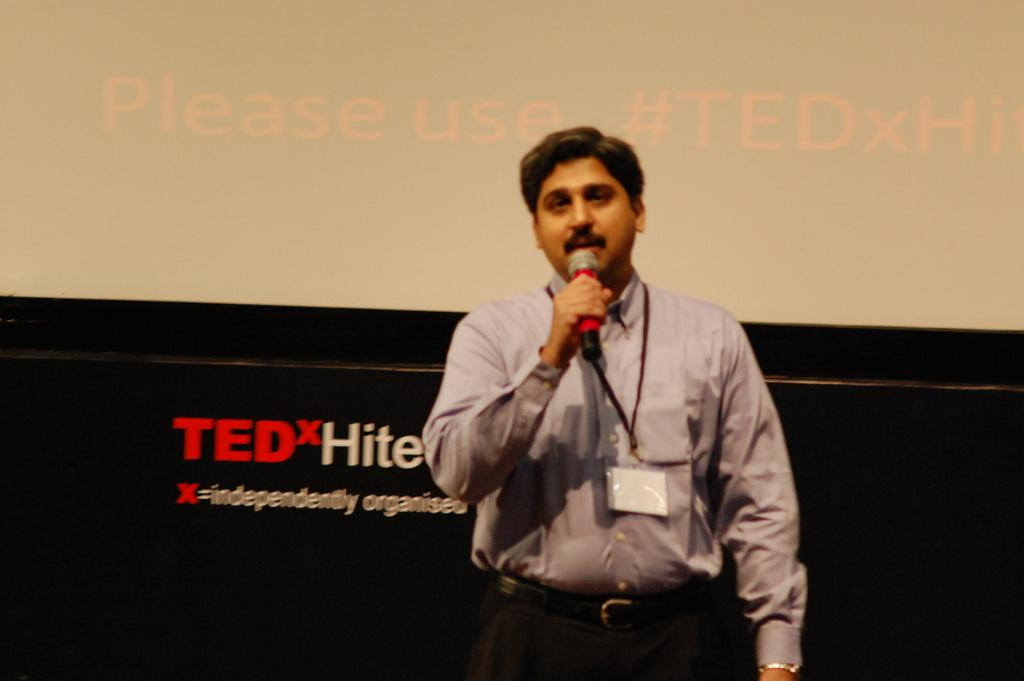What is the man doing on the stage in the image? The man is standing on the stage and talking. What is the man wearing that identifies him? The man is wearing an ID card. What is the man holding in his hand? The man is holding a microphone in his hand. What can be seen in the background of the image? There is a screen in the background. What time is displayed on the watch the man is wearing in the image? The man is not wearing a watch in the image. 